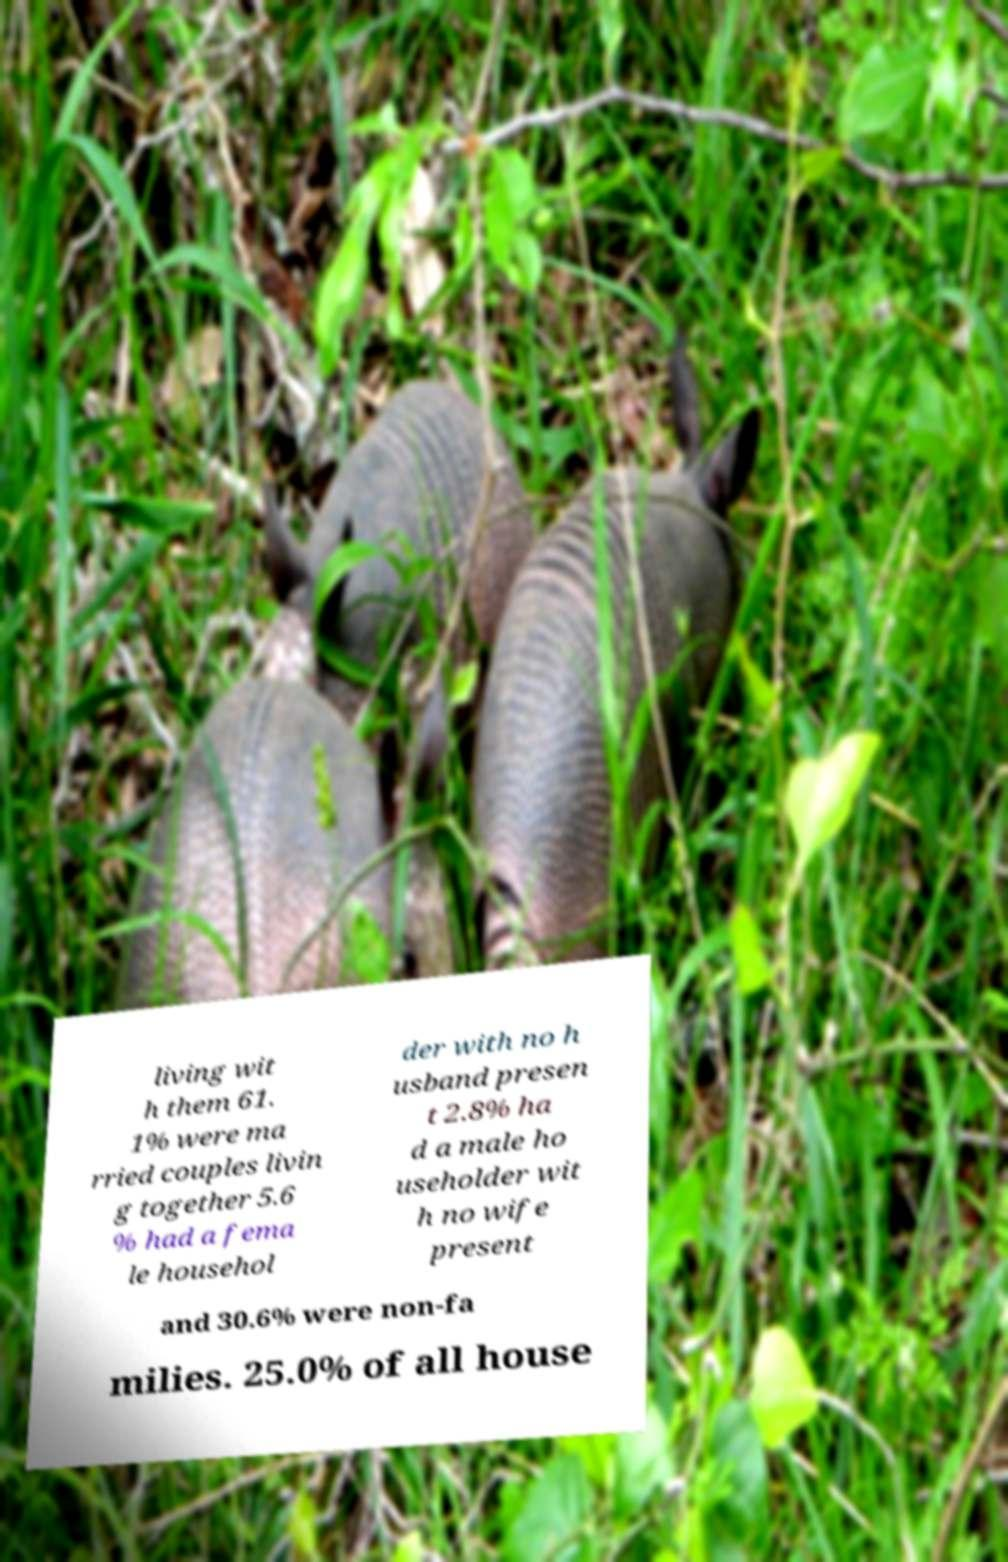Can you read and provide the text displayed in the image?This photo seems to have some interesting text. Can you extract and type it out for me? living wit h them 61. 1% were ma rried couples livin g together 5.6 % had a fema le househol der with no h usband presen t 2.8% ha d a male ho useholder wit h no wife present and 30.6% were non-fa milies. 25.0% of all house 